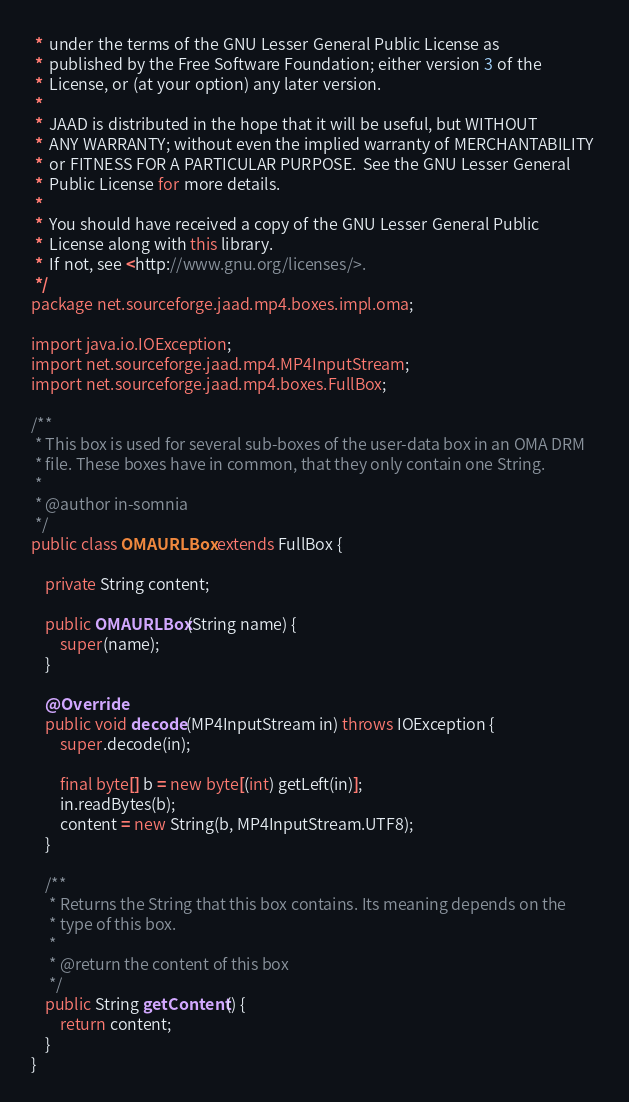Convert code to text. <code><loc_0><loc_0><loc_500><loc_500><_Java_> *  under the terms of the GNU Lesser General Public License as 
 *  published by the Free Software Foundation; either version 3 of the 
 *  License, or (at your option) any later version.
 *
 *  JAAD is distributed in the hope that it will be useful, but WITHOUT 
 *  ANY WARRANTY; without even the implied warranty of MERCHANTABILITY 
 *  or FITNESS FOR A PARTICULAR PURPOSE.  See the GNU Lesser General 
 *  Public License for more details.
 *
 *  You should have received a copy of the GNU Lesser General Public
 *  License along with this library.
 *  If not, see <http://www.gnu.org/licenses/>.
 */
package net.sourceforge.jaad.mp4.boxes.impl.oma;

import java.io.IOException;
import net.sourceforge.jaad.mp4.MP4InputStream;
import net.sourceforge.jaad.mp4.boxes.FullBox;

/**
 * This box is used for several sub-boxes of the user-data box in an OMA DRM 
 * file. These boxes have in common, that they only contain one String.
 * 
 * @author in-somnia
 */
public class OMAURLBox extends FullBox {

	private String content;

	public OMAURLBox(String name) {
		super(name);
	}

	@Override
	public void decode(MP4InputStream in) throws IOException {
		super.decode(in);

		final byte[] b = new byte[(int) getLeft(in)];
		in.readBytes(b);
		content = new String(b, MP4InputStream.UTF8);
	}

	/**
	 * Returns the String that this box contains. Its meaning depends on the 
	 * type of this box.
	 * 
	 * @return the content of this box
	 */
	public String getContent() {
		return content;
	}
}
</code> 